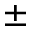<formula> <loc_0><loc_0><loc_500><loc_500>\pm</formula> 